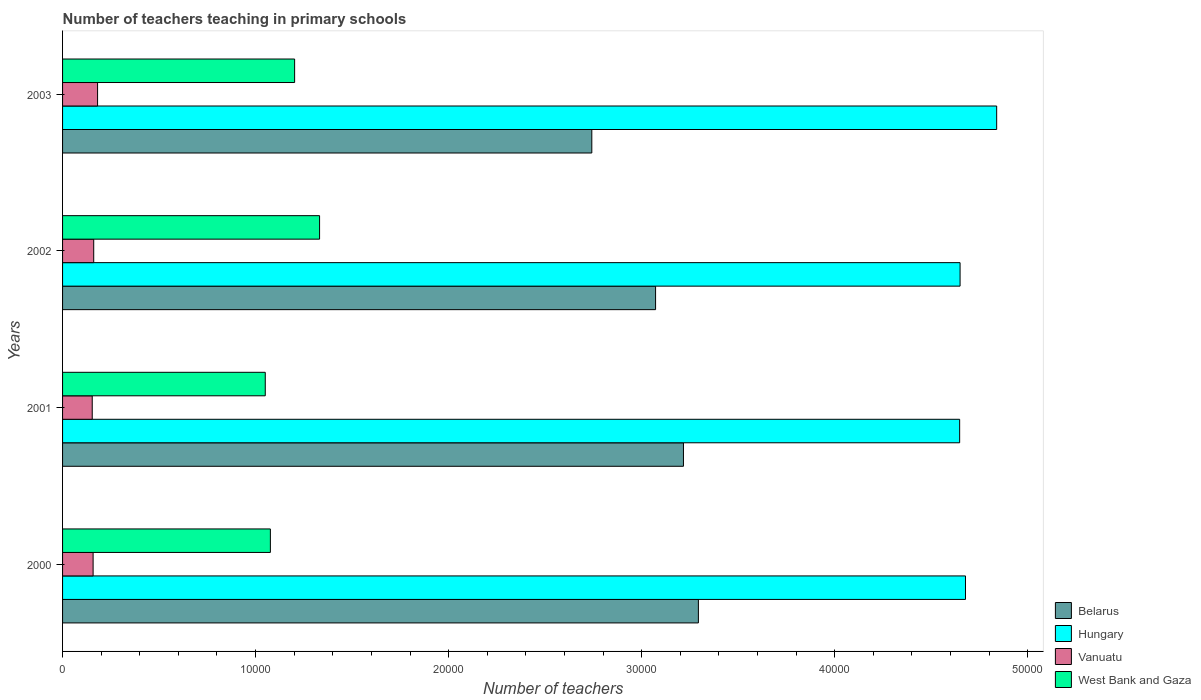How many groups of bars are there?
Keep it short and to the point. 4. Are the number of bars per tick equal to the number of legend labels?
Keep it short and to the point. Yes. Are the number of bars on each tick of the Y-axis equal?
Make the answer very short. Yes. How many bars are there on the 3rd tick from the bottom?
Your answer should be very brief. 4. What is the label of the 2nd group of bars from the top?
Your response must be concise. 2002. In how many cases, is the number of bars for a given year not equal to the number of legend labels?
Provide a succinct answer. 0. What is the number of teachers teaching in primary schools in West Bank and Gaza in 2002?
Your response must be concise. 1.33e+04. Across all years, what is the maximum number of teachers teaching in primary schools in Hungary?
Your answer should be compact. 4.84e+04. Across all years, what is the minimum number of teachers teaching in primary schools in Belarus?
Give a very brief answer. 2.74e+04. In which year was the number of teachers teaching in primary schools in Belarus maximum?
Ensure brevity in your answer.  2000. In which year was the number of teachers teaching in primary schools in Hungary minimum?
Your answer should be very brief. 2001. What is the total number of teachers teaching in primary schools in West Bank and Gaza in the graph?
Your answer should be compact. 4.66e+04. What is the difference between the number of teachers teaching in primary schools in Vanuatu in 2000 and that in 2003?
Your answer should be compact. -232. What is the difference between the number of teachers teaching in primary schools in Hungary in 2003 and the number of teachers teaching in primary schools in West Bank and Gaza in 2002?
Your answer should be very brief. 3.51e+04. What is the average number of teachers teaching in primary schools in Vanuatu per year?
Provide a short and direct response. 1636.75. In the year 2001, what is the difference between the number of teachers teaching in primary schools in West Bank and Gaza and number of teachers teaching in primary schools in Vanuatu?
Provide a succinct answer. 8964. In how many years, is the number of teachers teaching in primary schools in Belarus greater than 42000 ?
Offer a very short reply. 0. What is the ratio of the number of teachers teaching in primary schools in Vanuatu in 2000 to that in 2003?
Your response must be concise. 0.87. Is the number of teachers teaching in primary schools in West Bank and Gaza in 2001 less than that in 2002?
Provide a succinct answer. Yes. What is the difference between the highest and the second highest number of teachers teaching in primary schools in West Bank and Gaza?
Provide a short and direct response. 1293. What is the difference between the highest and the lowest number of teachers teaching in primary schools in West Bank and Gaza?
Offer a terse response. 2814. What does the 2nd bar from the top in 2001 represents?
Ensure brevity in your answer.  Vanuatu. What does the 3rd bar from the bottom in 2002 represents?
Provide a short and direct response. Vanuatu. Is it the case that in every year, the sum of the number of teachers teaching in primary schools in Vanuatu and number of teachers teaching in primary schools in Hungary is greater than the number of teachers teaching in primary schools in Belarus?
Provide a succinct answer. Yes. Are all the bars in the graph horizontal?
Offer a terse response. Yes. How many years are there in the graph?
Give a very brief answer. 4. What is the difference between two consecutive major ticks on the X-axis?
Provide a succinct answer. 10000. Where does the legend appear in the graph?
Your answer should be compact. Bottom right. How many legend labels are there?
Keep it short and to the point. 4. What is the title of the graph?
Offer a terse response. Number of teachers teaching in primary schools. Does "Turks and Caicos Islands" appear as one of the legend labels in the graph?
Your answer should be compact. No. What is the label or title of the X-axis?
Your answer should be compact. Number of teachers. What is the Number of teachers of Belarus in 2000?
Your answer should be very brief. 3.29e+04. What is the Number of teachers of Hungary in 2000?
Offer a terse response. 4.68e+04. What is the Number of teachers of Vanuatu in 2000?
Give a very brief answer. 1582. What is the Number of teachers in West Bank and Gaza in 2000?
Ensure brevity in your answer.  1.08e+04. What is the Number of teachers in Belarus in 2001?
Offer a terse response. 3.22e+04. What is the Number of teachers in Hungary in 2001?
Keep it short and to the point. 4.65e+04. What is the Number of teachers in Vanuatu in 2001?
Your response must be concise. 1537. What is the Number of teachers in West Bank and Gaza in 2001?
Make the answer very short. 1.05e+04. What is the Number of teachers in Belarus in 2002?
Your answer should be compact. 3.07e+04. What is the Number of teachers in Hungary in 2002?
Your answer should be very brief. 4.65e+04. What is the Number of teachers of Vanuatu in 2002?
Offer a very short reply. 1614. What is the Number of teachers in West Bank and Gaza in 2002?
Keep it short and to the point. 1.33e+04. What is the Number of teachers of Belarus in 2003?
Give a very brief answer. 2.74e+04. What is the Number of teachers in Hungary in 2003?
Keep it short and to the point. 4.84e+04. What is the Number of teachers of Vanuatu in 2003?
Provide a succinct answer. 1814. What is the Number of teachers of West Bank and Gaza in 2003?
Make the answer very short. 1.20e+04. Across all years, what is the maximum Number of teachers of Belarus?
Offer a terse response. 3.29e+04. Across all years, what is the maximum Number of teachers of Hungary?
Your response must be concise. 4.84e+04. Across all years, what is the maximum Number of teachers in Vanuatu?
Provide a succinct answer. 1814. Across all years, what is the maximum Number of teachers of West Bank and Gaza?
Provide a short and direct response. 1.33e+04. Across all years, what is the minimum Number of teachers in Belarus?
Keep it short and to the point. 2.74e+04. Across all years, what is the minimum Number of teachers in Hungary?
Ensure brevity in your answer.  4.65e+04. Across all years, what is the minimum Number of teachers in Vanuatu?
Keep it short and to the point. 1537. Across all years, what is the minimum Number of teachers of West Bank and Gaza?
Give a very brief answer. 1.05e+04. What is the total Number of teachers in Belarus in the graph?
Your response must be concise. 1.23e+05. What is the total Number of teachers of Hungary in the graph?
Offer a terse response. 1.88e+05. What is the total Number of teachers of Vanuatu in the graph?
Keep it short and to the point. 6547. What is the total Number of teachers in West Bank and Gaza in the graph?
Ensure brevity in your answer.  4.66e+04. What is the difference between the Number of teachers of Belarus in 2000 and that in 2001?
Give a very brief answer. 774. What is the difference between the Number of teachers in Hungary in 2000 and that in 2001?
Provide a succinct answer. 302. What is the difference between the Number of teachers of Vanuatu in 2000 and that in 2001?
Keep it short and to the point. 45. What is the difference between the Number of teachers of West Bank and Gaza in 2000 and that in 2001?
Keep it short and to the point. 265. What is the difference between the Number of teachers of Belarus in 2000 and that in 2002?
Your answer should be very brief. 2218. What is the difference between the Number of teachers of Hungary in 2000 and that in 2002?
Ensure brevity in your answer.  280. What is the difference between the Number of teachers in Vanuatu in 2000 and that in 2002?
Make the answer very short. -32. What is the difference between the Number of teachers in West Bank and Gaza in 2000 and that in 2002?
Offer a very short reply. -2549. What is the difference between the Number of teachers in Belarus in 2000 and that in 2003?
Provide a succinct answer. 5522. What is the difference between the Number of teachers of Hungary in 2000 and that in 2003?
Offer a terse response. -1616. What is the difference between the Number of teachers in Vanuatu in 2000 and that in 2003?
Give a very brief answer. -232. What is the difference between the Number of teachers in West Bank and Gaza in 2000 and that in 2003?
Offer a very short reply. -1256. What is the difference between the Number of teachers in Belarus in 2001 and that in 2002?
Keep it short and to the point. 1444. What is the difference between the Number of teachers of Vanuatu in 2001 and that in 2002?
Provide a succinct answer. -77. What is the difference between the Number of teachers of West Bank and Gaza in 2001 and that in 2002?
Your response must be concise. -2814. What is the difference between the Number of teachers in Belarus in 2001 and that in 2003?
Your answer should be compact. 4748. What is the difference between the Number of teachers of Hungary in 2001 and that in 2003?
Provide a succinct answer. -1918. What is the difference between the Number of teachers of Vanuatu in 2001 and that in 2003?
Ensure brevity in your answer.  -277. What is the difference between the Number of teachers of West Bank and Gaza in 2001 and that in 2003?
Your answer should be compact. -1521. What is the difference between the Number of teachers of Belarus in 2002 and that in 2003?
Keep it short and to the point. 3304. What is the difference between the Number of teachers in Hungary in 2002 and that in 2003?
Your answer should be compact. -1896. What is the difference between the Number of teachers of Vanuatu in 2002 and that in 2003?
Your response must be concise. -200. What is the difference between the Number of teachers in West Bank and Gaza in 2002 and that in 2003?
Your response must be concise. 1293. What is the difference between the Number of teachers in Belarus in 2000 and the Number of teachers in Hungary in 2001?
Make the answer very short. -1.35e+04. What is the difference between the Number of teachers of Belarus in 2000 and the Number of teachers of Vanuatu in 2001?
Offer a very short reply. 3.14e+04. What is the difference between the Number of teachers in Belarus in 2000 and the Number of teachers in West Bank and Gaza in 2001?
Your answer should be compact. 2.24e+04. What is the difference between the Number of teachers in Hungary in 2000 and the Number of teachers in Vanuatu in 2001?
Your answer should be compact. 4.52e+04. What is the difference between the Number of teachers in Hungary in 2000 and the Number of teachers in West Bank and Gaza in 2001?
Provide a succinct answer. 3.63e+04. What is the difference between the Number of teachers in Vanuatu in 2000 and the Number of teachers in West Bank and Gaza in 2001?
Ensure brevity in your answer.  -8919. What is the difference between the Number of teachers in Belarus in 2000 and the Number of teachers in Hungary in 2002?
Your answer should be very brief. -1.36e+04. What is the difference between the Number of teachers in Belarus in 2000 and the Number of teachers in Vanuatu in 2002?
Ensure brevity in your answer.  3.13e+04. What is the difference between the Number of teachers of Belarus in 2000 and the Number of teachers of West Bank and Gaza in 2002?
Provide a succinct answer. 1.96e+04. What is the difference between the Number of teachers of Hungary in 2000 and the Number of teachers of Vanuatu in 2002?
Make the answer very short. 4.52e+04. What is the difference between the Number of teachers of Hungary in 2000 and the Number of teachers of West Bank and Gaza in 2002?
Your response must be concise. 3.35e+04. What is the difference between the Number of teachers in Vanuatu in 2000 and the Number of teachers in West Bank and Gaza in 2002?
Provide a succinct answer. -1.17e+04. What is the difference between the Number of teachers in Belarus in 2000 and the Number of teachers in Hungary in 2003?
Ensure brevity in your answer.  -1.55e+04. What is the difference between the Number of teachers in Belarus in 2000 and the Number of teachers in Vanuatu in 2003?
Ensure brevity in your answer.  3.11e+04. What is the difference between the Number of teachers in Belarus in 2000 and the Number of teachers in West Bank and Gaza in 2003?
Provide a succinct answer. 2.09e+04. What is the difference between the Number of teachers in Hungary in 2000 and the Number of teachers in Vanuatu in 2003?
Offer a very short reply. 4.50e+04. What is the difference between the Number of teachers of Hungary in 2000 and the Number of teachers of West Bank and Gaza in 2003?
Your response must be concise. 3.48e+04. What is the difference between the Number of teachers in Vanuatu in 2000 and the Number of teachers in West Bank and Gaza in 2003?
Offer a terse response. -1.04e+04. What is the difference between the Number of teachers in Belarus in 2001 and the Number of teachers in Hungary in 2002?
Offer a very short reply. -1.43e+04. What is the difference between the Number of teachers of Belarus in 2001 and the Number of teachers of Vanuatu in 2002?
Your response must be concise. 3.06e+04. What is the difference between the Number of teachers of Belarus in 2001 and the Number of teachers of West Bank and Gaza in 2002?
Keep it short and to the point. 1.89e+04. What is the difference between the Number of teachers in Hungary in 2001 and the Number of teachers in Vanuatu in 2002?
Your answer should be very brief. 4.49e+04. What is the difference between the Number of teachers of Hungary in 2001 and the Number of teachers of West Bank and Gaza in 2002?
Offer a very short reply. 3.32e+04. What is the difference between the Number of teachers of Vanuatu in 2001 and the Number of teachers of West Bank and Gaza in 2002?
Your response must be concise. -1.18e+04. What is the difference between the Number of teachers in Belarus in 2001 and the Number of teachers in Hungary in 2003?
Your answer should be very brief. -1.62e+04. What is the difference between the Number of teachers in Belarus in 2001 and the Number of teachers in Vanuatu in 2003?
Provide a succinct answer. 3.04e+04. What is the difference between the Number of teachers of Belarus in 2001 and the Number of teachers of West Bank and Gaza in 2003?
Give a very brief answer. 2.01e+04. What is the difference between the Number of teachers of Hungary in 2001 and the Number of teachers of Vanuatu in 2003?
Make the answer very short. 4.47e+04. What is the difference between the Number of teachers in Hungary in 2001 and the Number of teachers in West Bank and Gaza in 2003?
Give a very brief answer. 3.45e+04. What is the difference between the Number of teachers in Vanuatu in 2001 and the Number of teachers in West Bank and Gaza in 2003?
Your answer should be compact. -1.05e+04. What is the difference between the Number of teachers of Belarus in 2002 and the Number of teachers of Hungary in 2003?
Give a very brief answer. -1.77e+04. What is the difference between the Number of teachers of Belarus in 2002 and the Number of teachers of Vanuatu in 2003?
Give a very brief answer. 2.89e+04. What is the difference between the Number of teachers in Belarus in 2002 and the Number of teachers in West Bank and Gaza in 2003?
Offer a very short reply. 1.87e+04. What is the difference between the Number of teachers of Hungary in 2002 and the Number of teachers of Vanuatu in 2003?
Provide a short and direct response. 4.47e+04. What is the difference between the Number of teachers of Hungary in 2002 and the Number of teachers of West Bank and Gaza in 2003?
Give a very brief answer. 3.45e+04. What is the difference between the Number of teachers of Vanuatu in 2002 and the Number of teachers of West Bank and Gaza in 2003?
Provide a short and direct response. -1.04e+04. What is the average Number of teachers in Belarus per year?
Keep it short and to the point. 3.08e+04. What is the average Number of teachers in Hungary per year?
Provide a short and direct response. 4.70e+04. What is the average Number of teachers in Vanuatu per year?
Your response must be concise. 1636.75. What is the average Number of teachers in West Bank and Gaza per year?
Give a very brief answer. 1.17e+04. In the year 2000, what is the difference between the Number of teachers of Belarus and Number of teachers of Hungary?
Provide a succinct answer. -1.38e+04. In the year 2000, what is the difference between the Number of teachers of Belarus and Number of teachers of Vanuatu?
Your response must be concise. 3.14e+04. In the year 2000, what is the difference between the Number of teachers in Belarus and Number of teachers in West Bank and Gaza?
Provide a succinct answer. 2.22e+04. In the year 2000, what is the difference between the Number of teachers of Hungary and Number of teachers of Vanuatu?
Make the answer very short. 4.52e+04. In the year 2000, what is the difference between the Number of teachers in Hungary and Number of teachers in West Bank and Gaza?
Give a very brief answer. 3.60e+04. In the year 2000, what is the difference between the Number of teachers in Vanuatu and Number of teachers in West Bank and Gaza?
Provide a succinct answer. -9184. In the year 2001, what is the difference between the Number of teachers in Belarus and Number of teachers in Hungary?
Provide a short and direct response. -1.43e+04. In the year 2001, what is the difference between the Number of teachers in Belarus and Number of teachers in Vanuatu?
Your response must be concise. 3.06e+04. In the year 2001, what is the difference between the Number of teachers in Belarus and Number of teachers in West Bank and Gaza?
Provide a short and direct response. 2.17e+04. In the year 2001, what is the difference between the Number of teachers in Hungary and Number of teachers in Vanuatu?
Make the answer very short. 4.49e+04. In the year 2001, what is the difference between the Number of teachers of Hungary and Number of teachers of West Bank and Gaza?
Your answer should be very brief. 3.60e+04. In the year 2001, what is the difference between the Number of teachers in Vanuatu and Number of teachers in West Bank and Gaza?
Make the answer very short. -8964. In the year 2002, what is the difference between the Number of teachers of Belarus and Number of teachers of Hungary?
Give a very brief answer. -1.58e+04. In the year 2002, what is the difference between the Number of teachers of Belarus and Number of teachers of Vanuatu?
Your answer should be very brief. 2.91e+04. In the year 2002, what is the difference between the Number of teachers in Belarus and Number of teachers in West Bank and Gaza?
Provide a short and direct response. 1.74e+04. In the year 2002, what is the difference between the Number of teachers of Hungary and Number of teachers of Vanuatu?
Keep it short and to the point. 4.49e+04. In the year 2002, what is the difference between the Number of teachers in Hungary and Number of teachers in West Bank and Gaza?
Give a very brief answer. 3.32e+04. In the year 2002, what is the difference between the Number of teachers of Vanuatu and Number of teachers of West Bank and Gaza?
Your answer should be very brief. -1.17e+04. In the year 2003, what is the difference between the Number of teachers in Belarus and Number of teachers in Hungary?
Keep it short and to the point. -2.10e+04. In the year 2003, what is the difference between the Number of teachers of Belarus and Number of teachers of Vanuatu?
Your response must be concise. 2.56e+04. In the year 2003, what is the difference between the Number of teachers of Belarus and Number of teachers of West Bank and Gaza?
Offer a very short reply. 1.54e+04. In the year 2003, what is the difference between the Number of teachers in Hungary and Number of teachers in Vanuatu?
Provide a succinct answer. 4.66e+04. In the year 2003, what is the difference between the Number of teachers of Hungary and Number of teachers of West Bank and Gaza?
Ensure brevity in your answer.  3.64e+04. In the year 2003, what is the difference between the Number of teachers of Vanuatu and Number of teachers of West Bank and Gaza?
Your response must be concise. -1.02e+04. What is the ratio of the Number of teachers of Belarus in 2000 to that in 2001?
Give a very brief answer. 1.02. What is the ratio of the Number of teachers of Vanuatu in 2000 to that in 2001?
Keep it short and to the point. 1.03. What is the ratio of the Number of teachers of West Bank and Gaza in 2000 to that in 2001?
Make the answer very short. 1.03. What is the ratio of the Number of teachers in Belarus in 2000 to that in 2002?
Provide a short and direct response. 1.07. What is the ratio of the Number of teachers in Hungary in 2000 to that in 2002?
Ensure brevity in your answer.  1.01. What is the ratio of the Number of teachers in Vanuatu in 2000 to that in 2002?
Provide a succinct answer. 0.98. What is the ratio of the Number of teachers in West Bank and Gaza in 2000 to that in 2002?
Your response must be concise. 0.81. What is the ratio of the Number of teachers of Belarus in 2000 to that in 2003?
Provide a short and direct response. 1.2. What is the ratio of the Number of teachers of Hungary in 2000 to that in 2003?
Your response must be concise. 0.97. What is the ratio of the Number of teachers in Vanuatu in 2000 to that in 2003?
Provide a short and direct response. 0.87. What is the ratio of the Number of teachers in West Bank and Gaza in 2000 to that in 2003?
Make the answer very short. 0.9. What is the ratio of the Number of teachers in Belarus in 2001 to that in 2002?
Offer a very short reply. 1.05. What is the ratio of the Number of teachers of Vanuatu in 2001 to that in 2002?
Your answer should be compact. 0.95. What is the ratio of the Number of teachers of West Bank and Gaza in 2001 to that in 2002?
Your answer should be compact. 0.79. What is the ratio of the Number of teachers of Belarus in 2001 to that in 2003?
Provide a succinct answer. 1.17. What is the ratio of the Number of teachers in Hungary in 2001 to that in 2003?
Your response must be concise. 0.96. What is the ratio of the Number of teachers in Vanuatu in 2001 to that in 2003?
Provide a short and direct response. 0.85. What is the ratio of the Number of teachers in West Bank and Gaza in 2001 to that in 2003?
Make the answer very short. 0.87. What is the ratio of the Number of teachers of Belarus in 2002 to that in 2003?
Offer a very short reply. 1.12. What is the ratio of the Number of teachers in Hungary in 2002 to that in 2003?
Ensure brevity in your answer.  0.96. What is the ratio of the Number of teachers in Vanuatu in 2002 to that in 2003?
Give a very brief answer. 0.89. What is the ratio of the Number of teachers of West Bank and Gaza in 2002 to that in 2003?
Your answer should be compact. 1.11. What is the difference between the highest and the second highest Number of teachers in Belarus?
Keep it short and to the point. 774. What is the difference between the highest and the second highest Number of teachers of Hungary?
Provide a short and direct response. 1616. What is the difference between the highest and the second highest Number of teachers in Vanuatu?
Your answer should be compact. 200. What is the difference between the highest and the second highest Number of teachers of West Bank and Gaza?
Provide a short and direct response. 1293. What is the difference between the highest and the lowest Number of teachers of Belarus?
Ensure brevity in your answer.  5522. What is the difference between the highest and the lowest Number of teachers of Hungary?
Offer a terse response. 1918. What is the difference between the highest and the lowest Number of teachers of Vanuatu?
Make the answer very short. 277. What is the difference between the highest and the lowest Number of teachers of West Bank and Gaza?
Your answer should be very brief. 2814. 